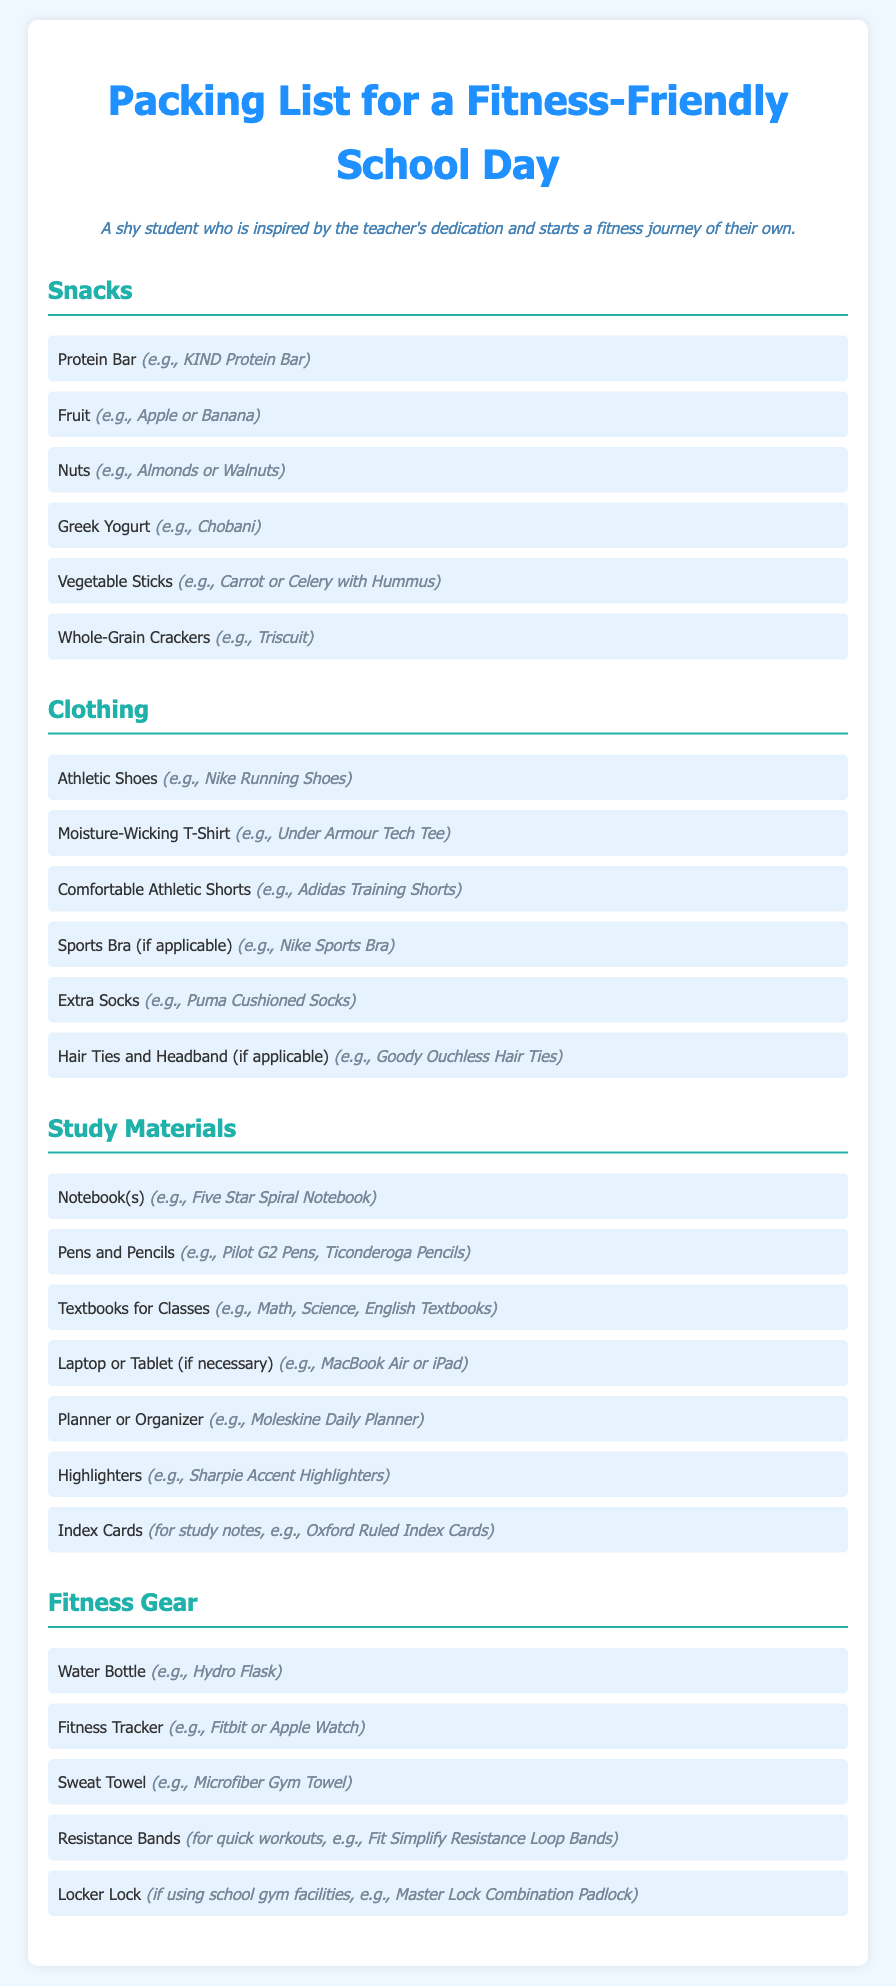What snacks are listed? The document provides a list of snacks suitable for a fitness-friendly school day.
Answer: Protein Bar, Fruit, Nuts, Greek Yogurt, Vegetable Sticks, Whole-Grain Crackers How many items are in the clothing section? The clothing section contains several listed apparel suitable for fitness activities.
Answer: 6 What type of water bottle is recommended? A specific brand of water bottle is suggested for hydration during school and fitness activities.
Answer: Hydro Flask Which fitness device is mentioned in the list? The document mentions a type of wearable technology used to track fitness activities.
Answer: Fitbit or Apple Watch What is the last item in the study materials section? The document lists various study materials, ending with a specific type of note-taking card.
Answer: Oxford Ruled Index Cards How many sections are there in the packing list? The packing list contains multiple sections, each addressing different categories of items.
Answer: 4 